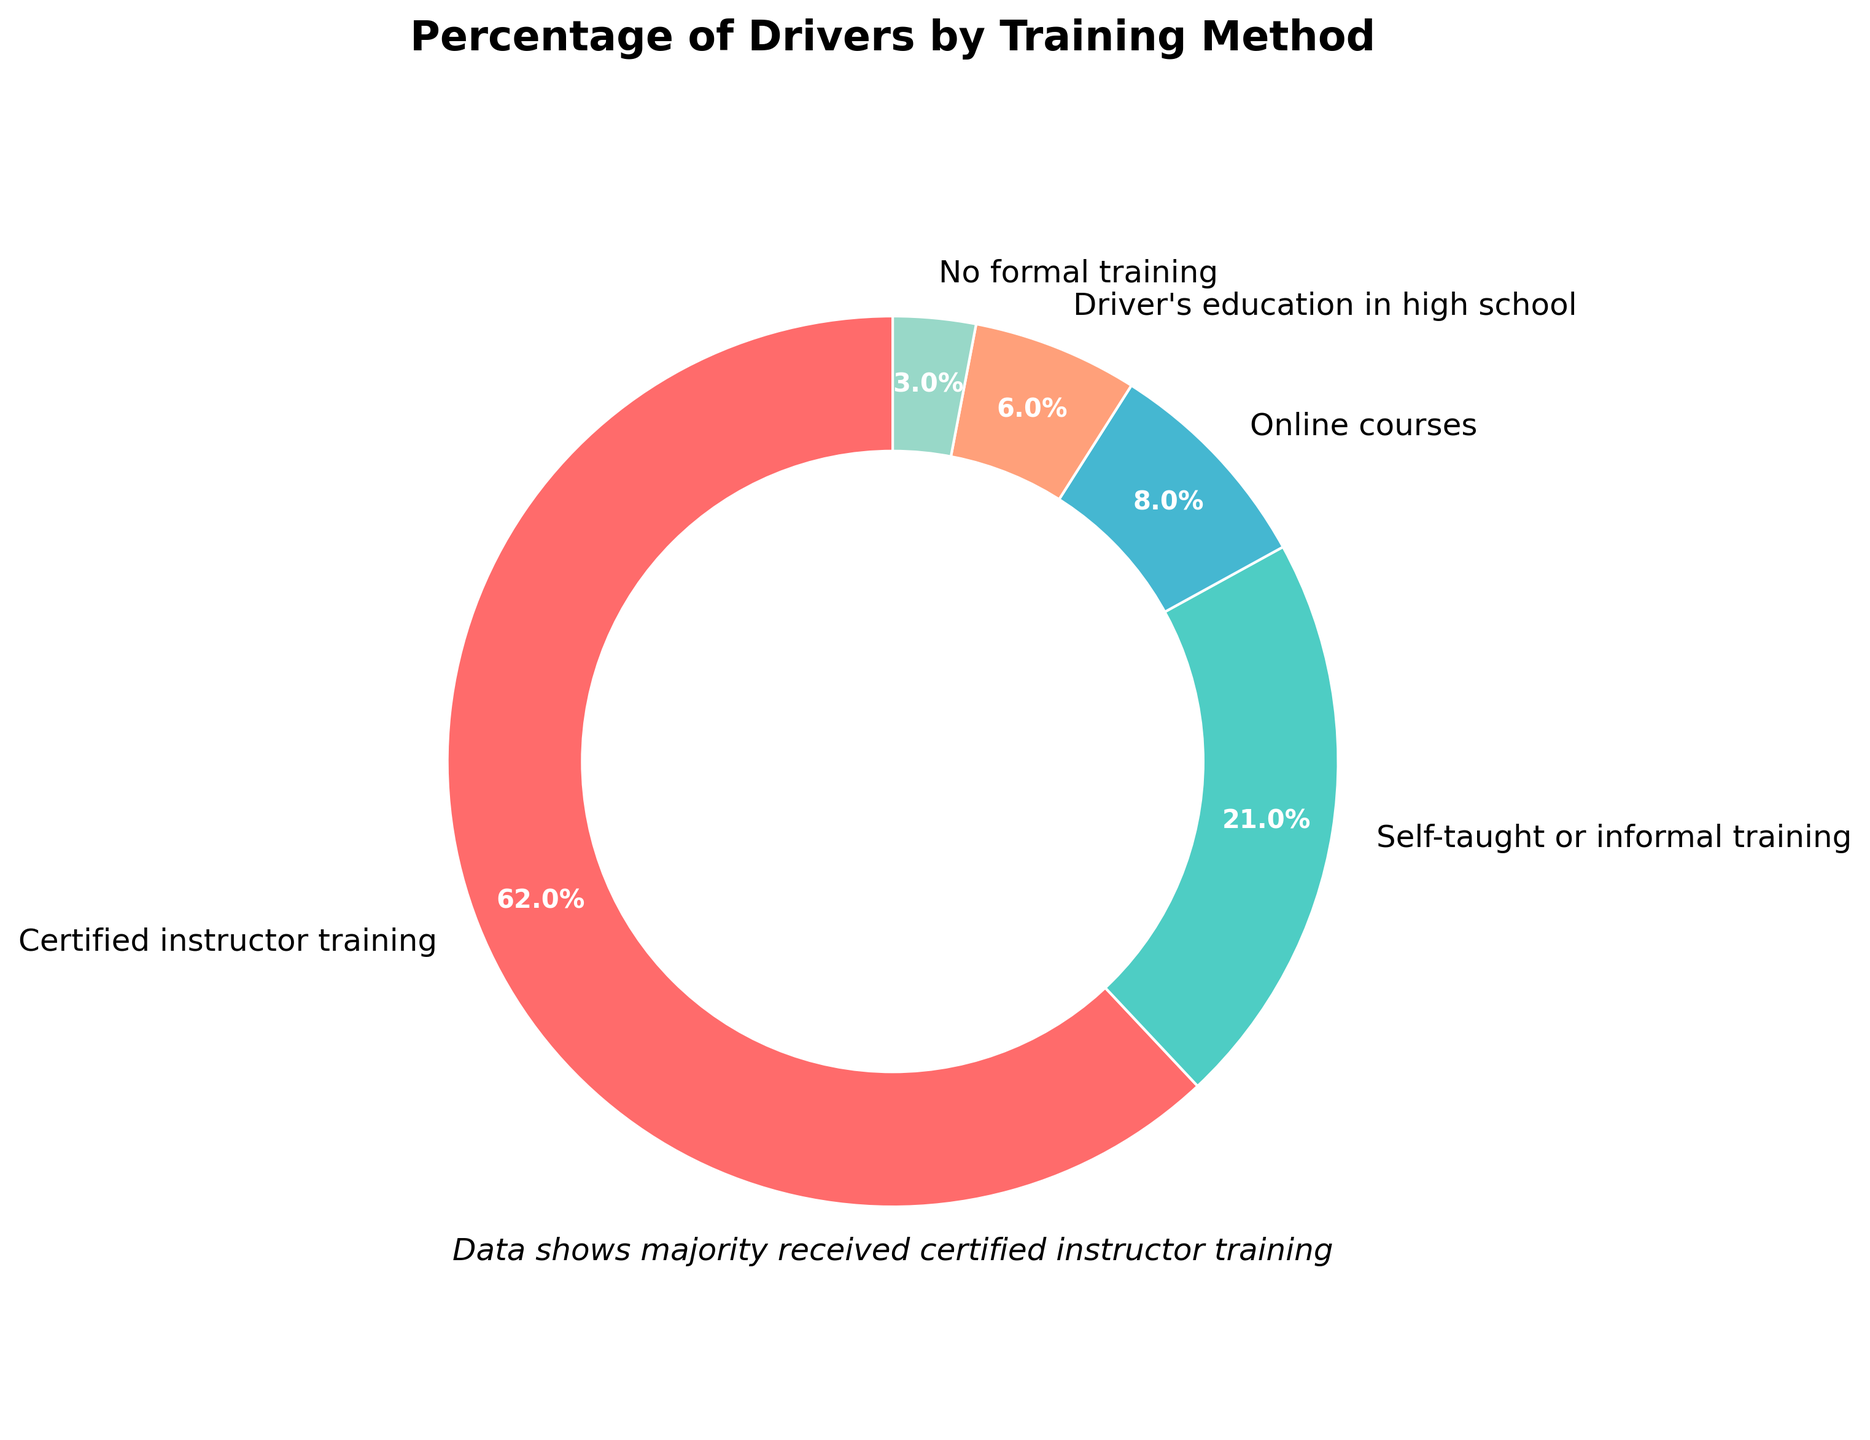What percentage of drivers received certified instructor training? To find this, locate the slice labeled "Certified instructor training" on the pie chart. The label should indicate the percentage directly.
Answer: 62% Which training method has the second highest percentage of drivers? Compare the sizes of the slices and their labels. The slice for "Self-taught or informal training" is the second largest.
Answer: Self-taught or informal training How many more drivers received certified instructor training than self-taught or informal training? Subtract the percentage of self-taught or informal training (21%) from the percentage of certified instructor training (62%).
Answer: 41% What is the combined percentage of drivers who received online courses and driver's education in high school? Add the percentages for "Online courses" (8%) and "Driver's education in high school" (6%).
Answer: 14% Is the percentage of drivers with no formal training higher or lower than those who took online courses? Compare the slices for "No formal training" (3%) and "Online courses" (8%).
Answer: Lower Which category has the smallest percentage of drivers? Identify the smallest slice, labeled "No formal training," with its percentage marked.
Answer: No formal training What is the total percentage of drivers who did not receive certified instructor training? Subtract the percentage for "Certified instructor training" (62%) from 100%.
Answer: 38% How does the size of the slice for driver's education in high school compare to the slice for self-taught or informal training? Compare the slices visually or by their percentages. Driver's education in high school is smaller (6%) than self-taught or informal training (21%).
Answer: Smaller If you combine the percentages of drivers who received certified instructor training and no formal training, what do you get? Add the percentages for "Certified instructor training" (62%) and "No formal training" (3%).
Answer: 65% Is the percentage of drivers who took online courses more than three times the percentage of those with no formal training? Compare the percentage for "Online courses" (8%) to three times the percentage for "No formal training" (3% x 3 = 9%). Since 8% is less than 9%, the answer is no.
Answer: No 